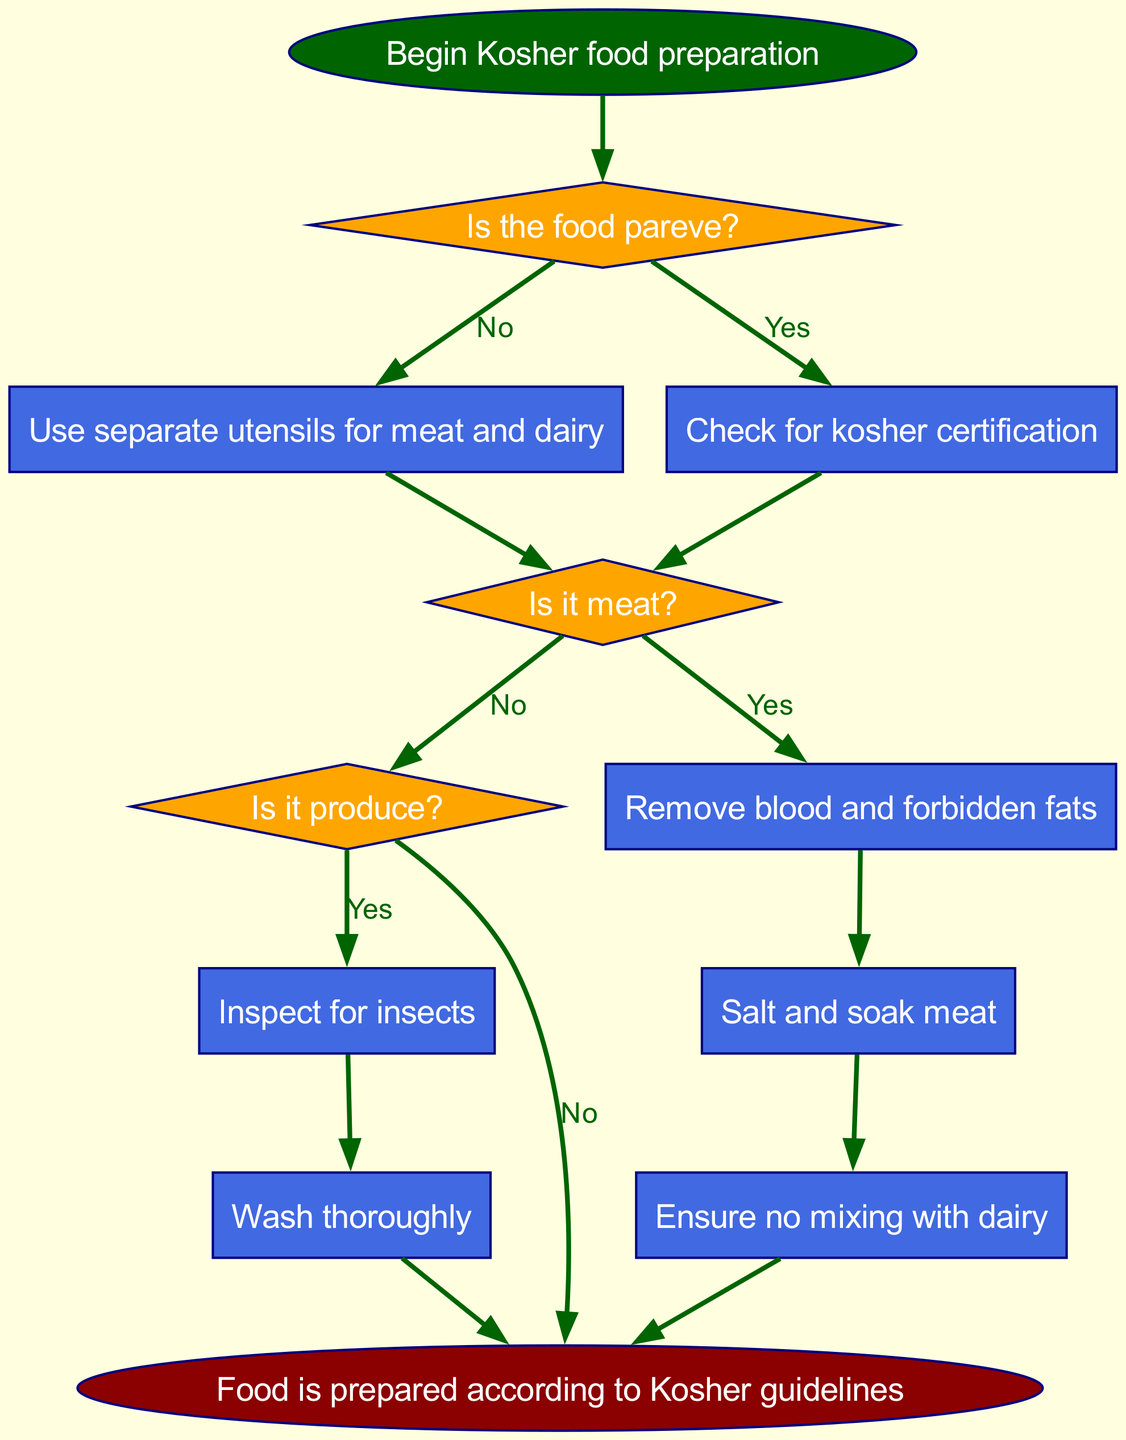What is the starting point of the diagram? The starting point of the diagram is labeled as "Begin Kosher food preparation," which is the first node in the flowchart.
Answer: Begin Kosher food preparation How many decision nodes are in the diagram? The diagram contains three decision nodes, which are the points where choices are made: "Is the food pareve?", "Is it meat?", and "Is it produce?".
Answer: 3 What process follows the decision node "Is it meat?" if the answer is "Yes"? If the answer is "Yes" to "Is it meat?", the following process is "Remove blood and forbidden fats." This process is directly connected to that decision node for "meat".
Answer: Remove blood and forbidden fats What happens when the food is identified as produce? When the food is identified as produce, the first action is "Inspect for insects," which is the subsequent process after the decision node "Is it produce?".
Answer: Inspect for insects What is the final outcome of the preparation process? The final outcome of the preparation process, as indicated by the last node in the diagram, is that the "Food is prepared according to Kosher guidelines." This is the concluding statement after all preceding processes.
Answer: Food is prepared according to Kosher guidelines If the food is not pareve, what is the next step? If the food is not pareve, the next step is to "Check for kosher certification," which follows the decision node "Is the food pareve?" when the answer is "No".
Answer: Check for kosher certification Are there any processes related to dairy? There are processes related to dairy specifically in the context of the requirement to "Ensure no mixing with dairy," which is a requirement that follows the "Salt and soak meat" process when handling meat.
Answer: Yes What is required of meat after confirming it is meat? After confirming the food is meat, the requirements are to "Remove blood and forbidden fats" followed by "Salt and soak meat," indicating a specific kosher preparation procedure for meat.
Answer: Remove blood and forbidden fats, Salt and soak meat 